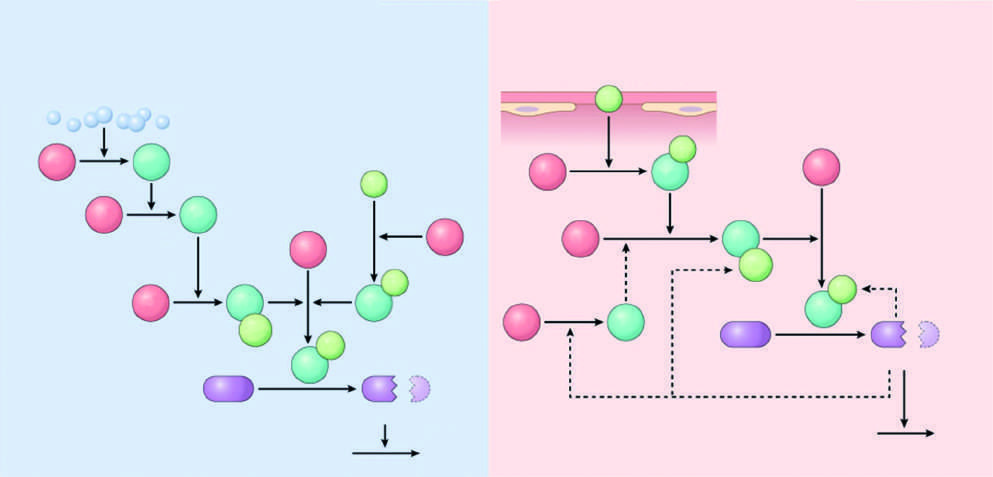what do the light green polypeptides correspond to?
Answer the question using a single word or phrase. Cofactors 